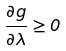<formula> <loc_0><loc_0><loc_500><loc_500>\frac { \partial g } { \partial \lambda } \geq 0</formula> 